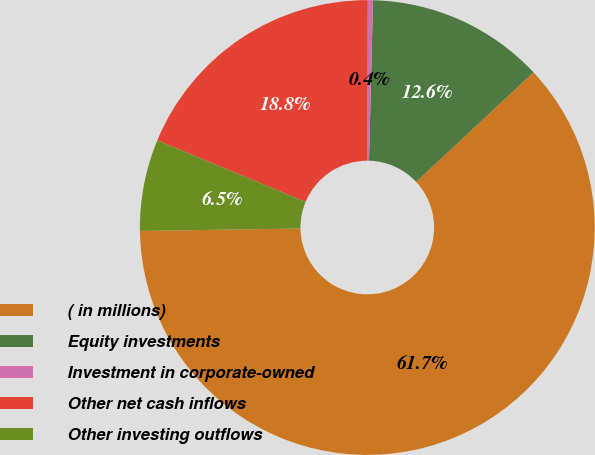Convert chart. <chart><loc_0><loc_0><loc_500><loc_500><pie_chart><fcel>( in millions)<fcel>Equity investments<fcel>Investment in corporate-owned<fcel>Other net cash inflows<fcel>Other investing outflows<nl><fcel>61.71%<fcel>12.64%<fcel>0.37%<fcel>18.77%<fcel>6.5%<nl></chart> 